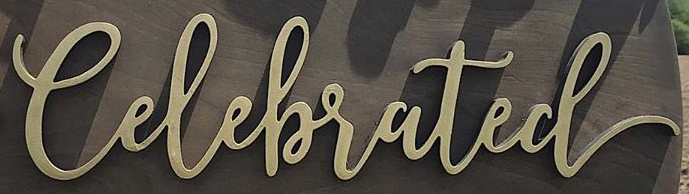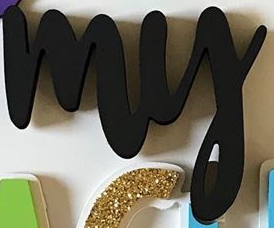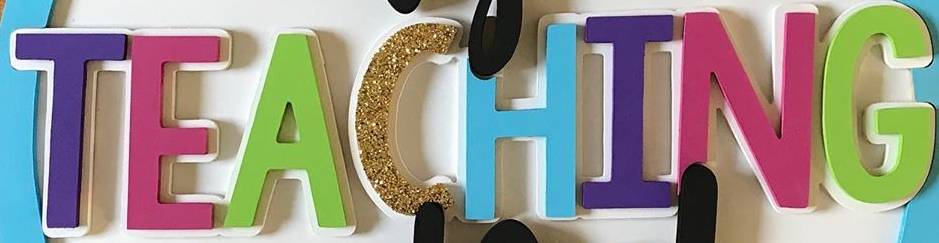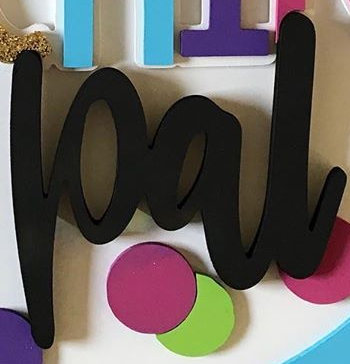Read the text content from these images in order, separated by a semicolon. Celebrated; my; TEACHING; pal 